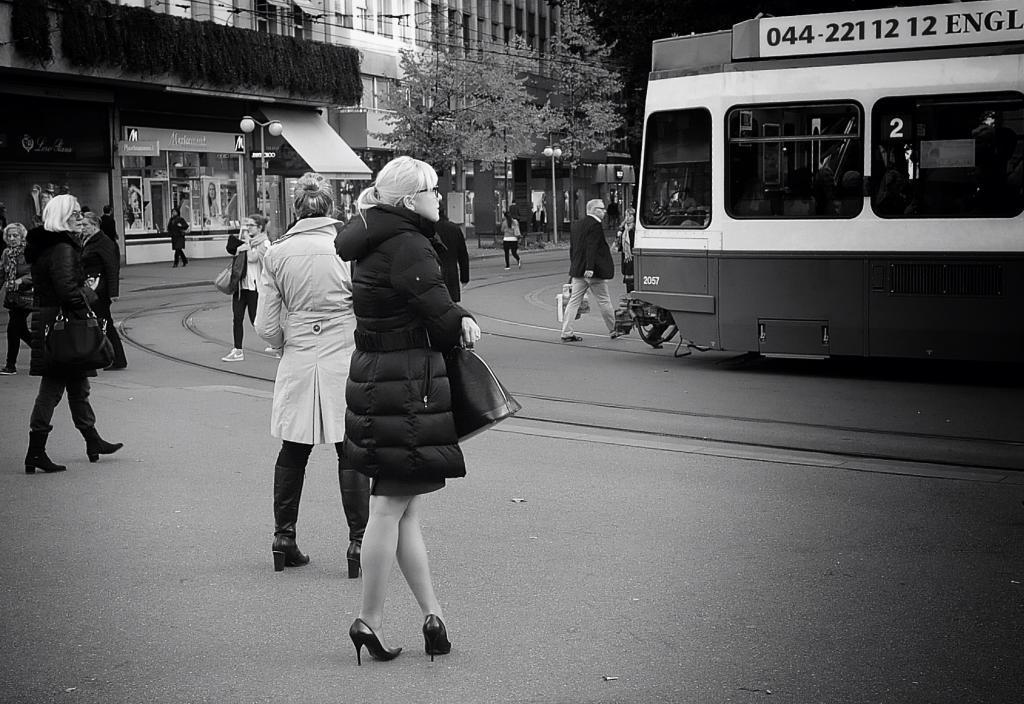In one or two sentences, can you explain what this image depicts? This is a black and white image. In the center of the image we can see woman standing on the road. In the background we can see train, railway tracks, persons, buildings, trees, street lights and stores. 